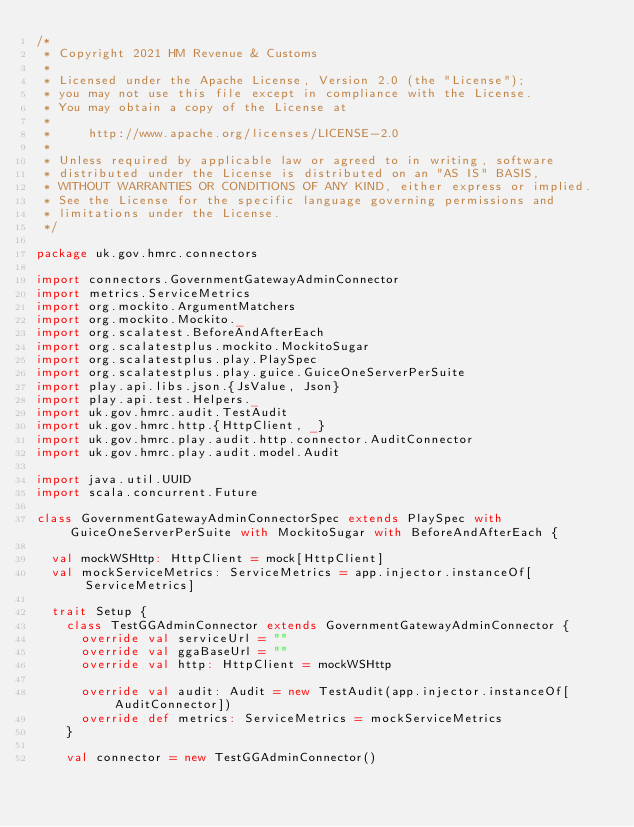Convert code to text. <code><loc_0><loc_0><loc_500><loc_500><_Scala_>/*
 * Copyright 2021 HM Revenue & Customs
 *
 * Licensed under the Apache License, Version 2.0 (the "License");
 * you may not use this file except in compliance with the License.
 * You may obtain a copy of the License at
 *
 *     http://www.apache.org/licenses/LICENSE-2.0
 *
 * Unless required by applicable law or agreed to in writing, software
 * distributed under the License is distributed on an "AS IS" BASIS,
 * WITHOUT WARRANTIES OR CONDITIONS OF ANY KIND, either express or implied.
 * See the License for the specific language governing permissions and
 * limitations under the License.
 */

package uk.gov.hmrc.connectors

import connectors.GovernmentGatewayAdminConnector
import metrics.ServiceMetrics
import org.mockito.ArgumentMatchers
import org.mockito.Mockito._
import org.scalatest.BeforeAndAfterEach
import org.scalatestplus.mockito.MockitoSugar
import org.scalatestplus.play.PlaySpec
import org.scalatestplus.play.guice.GuiceOneServerPerSuite
import play.api.libs.json.{JsValue, Json}
import play.api.test.Helpers._
import uk.gov.hmrc.audit.TestAudit
import uk.gov.hmrc.http.{HttpClient, _}
import uk.gov.hmrc.play.audit.http.connector.AuditConnector
import uk.gov.hmrc.play.audit.model.Audit

import java.util.UUID
import scala.concurrent.Future

class GovernmentGatewayAdminConnectorSpec extends PlaySpec with GuiceOneServerPerSuite with MockitoSugar with BeforeAndAfterEach {

  val mockWSHttp: HttpClient = mock[HttpClient]
  val mockServiceMetrics: ServiceMetrics = app.injector.instanceOf[ServiceMetrics]

  trait Setup {
    class TestGGAdminConnector extends GovernmentGatewayAdminConnector {
      override val serviceUrl = ""
      override val ggaBaseUrl = ""
      override val http: HttpClient = mockWSHttp

      override val audit: Audit = new TestAudit(app.injector.instanceOf[AuditConnector])
      override def metrics: ServiceMetrics = mockServiceMetrics
    }

    val connector = new TestGGAdminConnector()</code> 